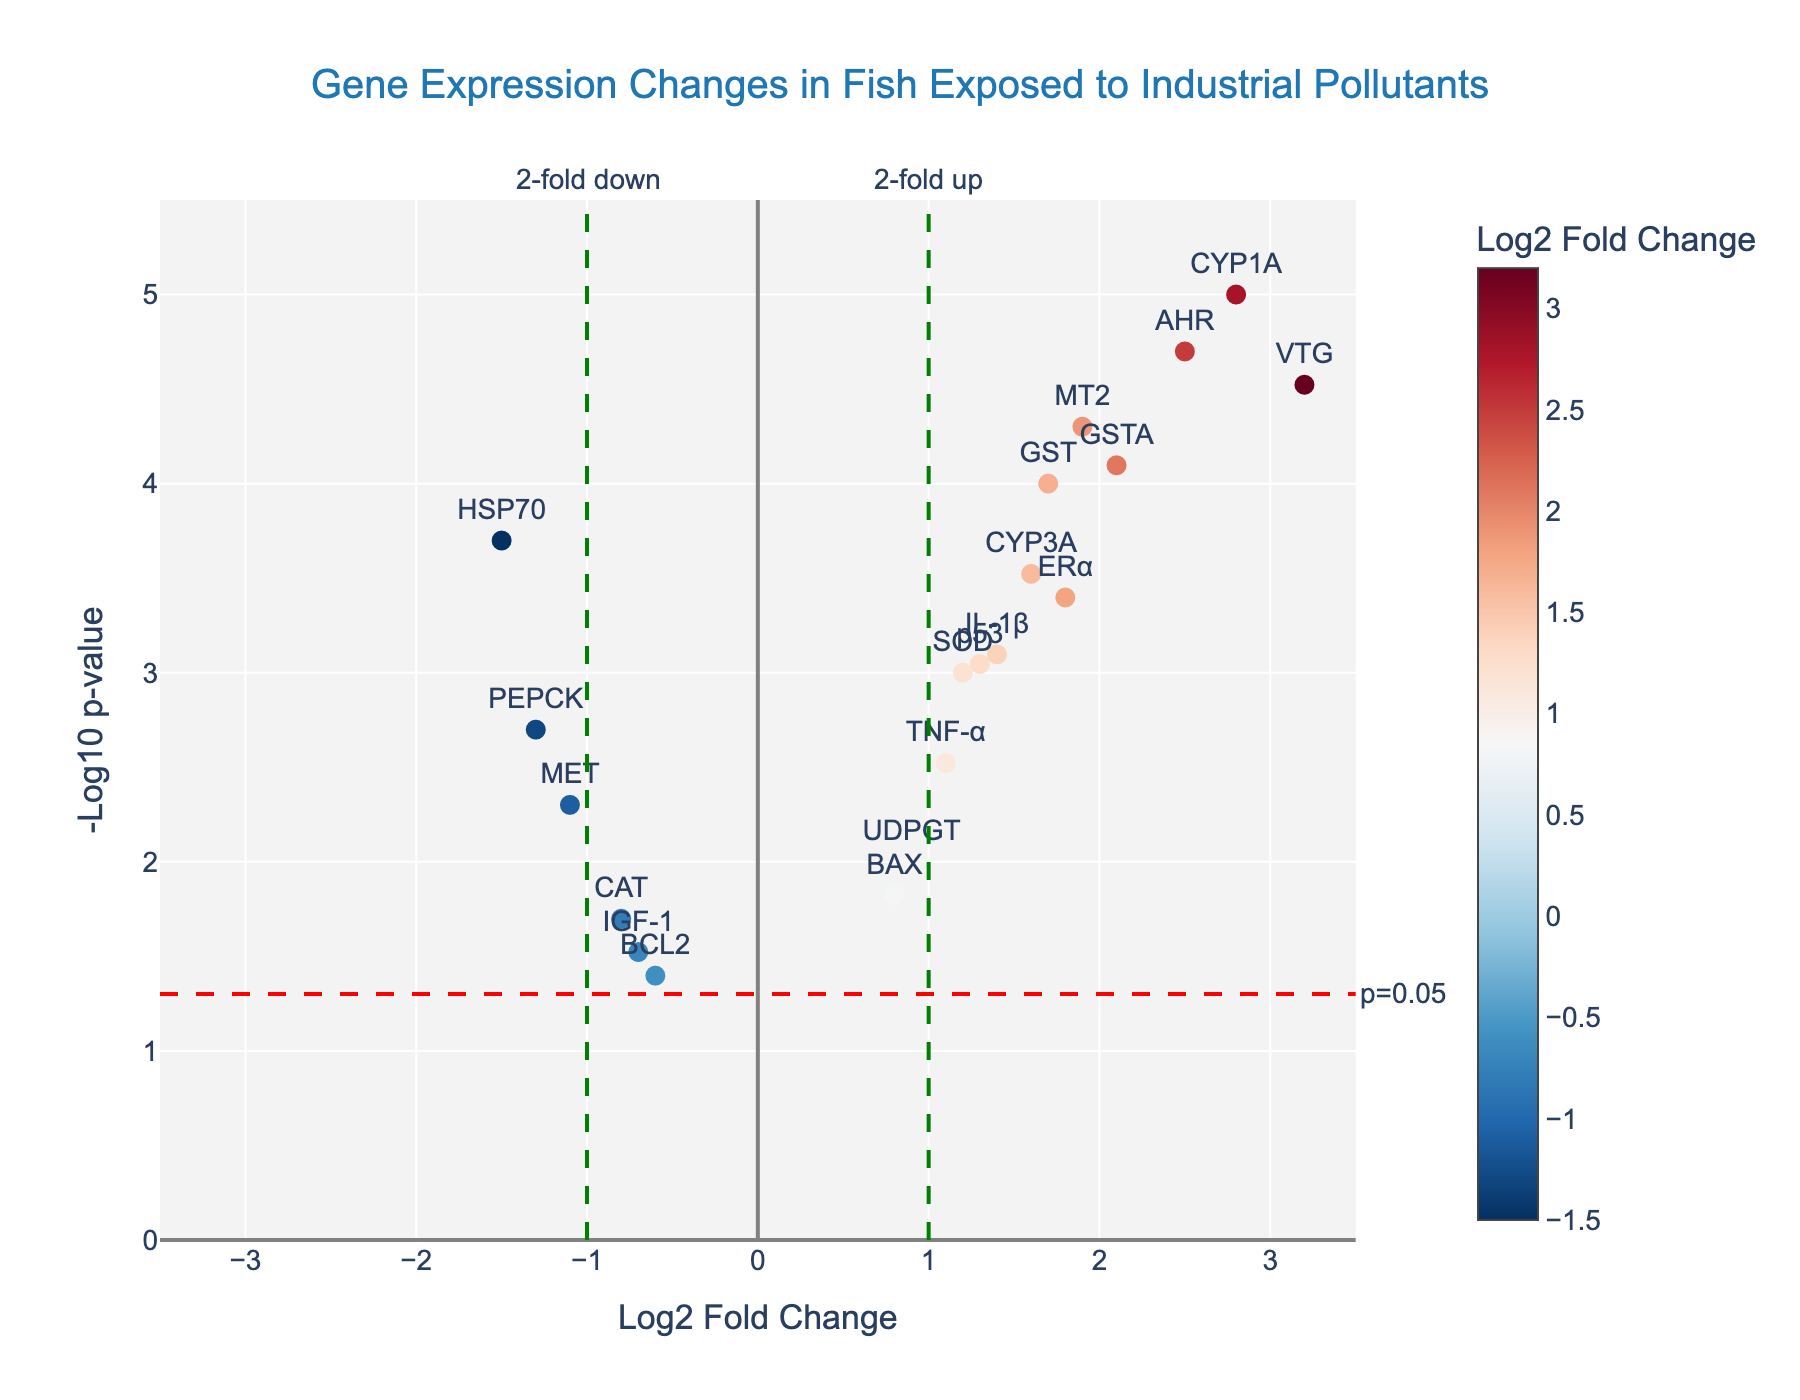What's the title of the plot? The title is usually displayed at the top of the figure. In this case, it reads "Gene Expression Changes in Fish Exposed to Industrial Pollutants".
Answer: Gene Expression Changes in Fish Exposed to Industrial Pollutants What are the x-axis and y-axis labels in the plot? The labels are specified in the layout settings of the plot. The x-axis is labeled "Log2 Fold Change" and the y-axis is labeled "-Log10 p-value".
Answer: Log2 Fold Change and -Log10 p-value How many genes have a log2 fold change greater than 2? To find the number of genes with a log2 fold change greater than 2, you look for points positioned to the right of the vertical fold change threshold at x=2 on the plot.
Answer: 3 genes Which gene has the highest log2 fold change and what is its corresponding p-value? The gene with the highest position along the x-axis corresponds to the highest log2 fold change. Here, VTG has the highest log2 fold change of 3.2 and a p-value of 0.00003.
Answer: VTG, 0.00003 Which genes have p-values lower than 0.05 but higher than 0.001? You find the points between the horizontal line indicating p=0.05 and the -log10(p-value) corresponding to 0.001. This includes CYP3A, SOD, p53, and ERα.
Answer: CYP3A, SOD, p53, ERα How many genes are upregulated (i.e., positive log2 fold change) and significant (p < 0.05)? First, find the genes with positive log2 fold changes (right of the y-axis). Among them, count those above the horizontal line at y=-log10(0.05).
Answer: 10 genes Which gene shows the most significant downregulation and what are its log2 fold change and p-value? The most significant downregulation is found by locating the gene with the lowest log2 fold change on the left of the plot. HSP70 shows the most significant downregulation with a log2 fold change of -1.5 and a p-value of 0.0002.
Answer: HSP70, -1.5, 0.0002 Which gene appears closest to the significance threshold line (p=0.05)? The gene closest to the y=-log10(0.05) line needs to be determined visually by identifying the point nearest to this threshold. This gene is CAT.
Answer: CAT Do more genes exhibit upregulation or downregulation in the plot? Count the genes on both sides of the y-axis. Upregulated genes (right) are more in number than downregulated ones (left).
Answer: More upregulated genes What is the fold change threshold indicated on the plot, and how is it represented? The threshold is a log2 fold change of ±1, represented by vertical dashed green lines marked "2-fold up" (x=1) and "2-fold down" (x=-1).
Answer: ±1, vertical dashed green lines 